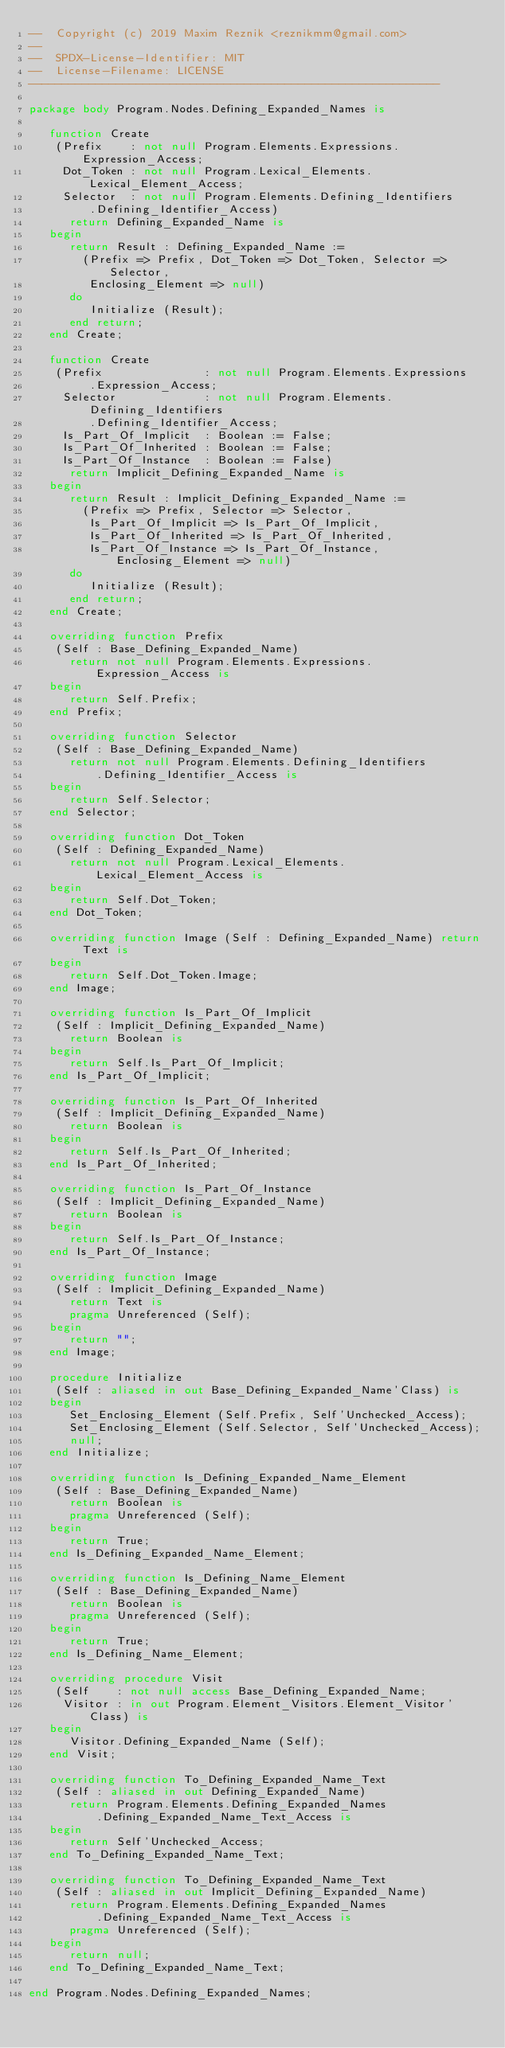Convert code to text. <code><loc_0><loc_0><loc_500><loc_500><_Ada_>--  Copyright (c) 2019 Maxim Reznik <reznikmm@gmail.com>
--
--  SPDX-License-Identifier: MIT
--  License-Filename: LICENSE
-------------------------------------------------------------

package body Program.Nodes.Defining_Expanded_Names is

   function Create
    (Prefix    : not null Program.Elements.Expressions.Expression_Access;
     Dot_Token : not null Program.Lexical_Elements.Lexical_Element_Access;
     Selector  : not null Program.Elements.Defining_Identifiers
         .Defining_Identifier_Access)
      return Defining_Expanded_Name is
   begin
      return Result : Defining_Expanded_Name :=
        (Prefix => Prefix, Dot_Token => Dot_Token, Selector => Selector,
         Enclosing_Element => null)
      do
         Initialize (Result);
      end return;
   end Create;

   function Create
    (Prefix               : not null Program.Elements.Expressions
         .Expression_Access;
     Selector             : not null Program.Elements.Defining_Identifiers
         .Defining_Identifier_Access;
     Is_Part_Of_Implicit  : Boolean := False;
     Is_Part_Of_Inherited : Boolean := False;
     Is_Part_Of_Instance  : Boolean := False)
      return Implicit_Defining_Expanded_Name is
   begin
      return Result : Implicit_Defining_Expanded_Name :=
        (Prefix => Prefix, Selector => Selector,
         Is_Part_Of_Implicit => Is_Part_Of_Implicit,
         Is_Part_Of_Inherited => Is_Part_Of_Inherited,
         Is_Part_Of_Instance => Is_Part_Of_Instance, Enclosing_Element => null)
      do
         Initialize (Result);
      end return;
   end Create;

   overriding function Prefix
    (Self : Base_Defining_Expanded_Name)
      return not null Program.Elements.Expressions.Expression_Access is
   begin
      return Self.Prefix;
   end Prefix;

   overriding function Selector
    (Self : Base_Defining_Expanded_Name)
      return not null Program.Elements.Defining_Identifiers
          .Defining_Identifier_Access is
   begin
      return Self.Selector;
   end Selector;

   overriding function Dot_Token
    (Self : Defining_Expanded_Name)
      return not null Program.Lexical_Elements.Lexical_Element_Access is
   begin
      return Self.Dot_Token;
   end Dot_Token;

   overriding function Image (Self : Defining_Expanded_Name) return Text is
   begin
      return Self.Dot_Token.Image;
   end Image;

   overriding function Is_Part_Of_Implicit
    (Self : Implicit_Defining_Expanded_Name)
      return Boolean is
   begin
      return Self.Is_Part_Of_Implicit;
   end Is_Part_Of_Implicit;

   overriding function Is_Part_Of_Inherited
    (Self : Implicit_Defining_Expanded_Name)
      return Boolean is
   begin
      return Self.Is_Part_Of_Inherited;
   end Is_Part_Of_Inherited;

   overriding function Is_Part_Of_Instance
    (Self : Implicit_Defining_Expanded_Name)
      return Boolean is
   begin
      return Self.Is_Part_Of_Instance;
   end Is_Part_Of_Instance;

   overriding function Image
    (Self : Implicit_Defining_Expanded_Name)
      return Text is
      pragma Unreferenced (Self);
   begin
      return "";
   end Image;

   procedure Initialize
    (Self : aliased in out Base_Defining_Expanded_Name'Class) is
   begin
      Set_Enclosing_Element (Self.Prefix, Self'Unchecked_Access);
      Set_Enclosing_Element (Self.Selector, Self'Unchecked_Access);
      null;
   end Initialize;

   overriding function Is_Defining_Expanded_Name_Element
    (Self : Base_Defining_Expanded_Name)
      return Boolean is
      pragma Unreferenced (Self);
   begin
      return True;
   end Is_Defining_Expanded_Name_Element;

   overriding function Is_Defining_Name_Element
    (Self : Base_Defining_Expanded_Name)
      return Boolean is
      pragma Unreferenced (Self);
   begin
      return True;
   end Is_Defining_Name_Element;

   overriding procedure Visit
    (Self    : not null access Base_Defining_Expanded_Name;
     Visitor : in out Program.Element_Visitors.Element_Visitor'Class) is
   begin
      Visitor.Defining_Expanded_Name (Self);
   end Visit;

   overriding function To_Defining_Expanded_Name_Text
    (Self : aliased in out Defining_Expanded_Name)
      return Program.Elements.Defining_Expanded_Names
          .Defining_Expanded_Name_Text_Access is
   begin
      return Self'Unchecked_Access;
   end To_Defining_Expanded_Name_Text;

   overriding function To_Defining_Expanded_Name_Text
    (Self : aliased in out Implicit_Defining_Expanded_Name)
      return Program.Elements.Defining_Expanded_Names
          .Defining_Expanded_Name_Text_Access is
      pragma Unreferenced (Self);
   begin
      return null;
   end To_Defining_Expanded_Name_Text;

end Program.Nodes.Defining_Expanded_Names;
</code> 